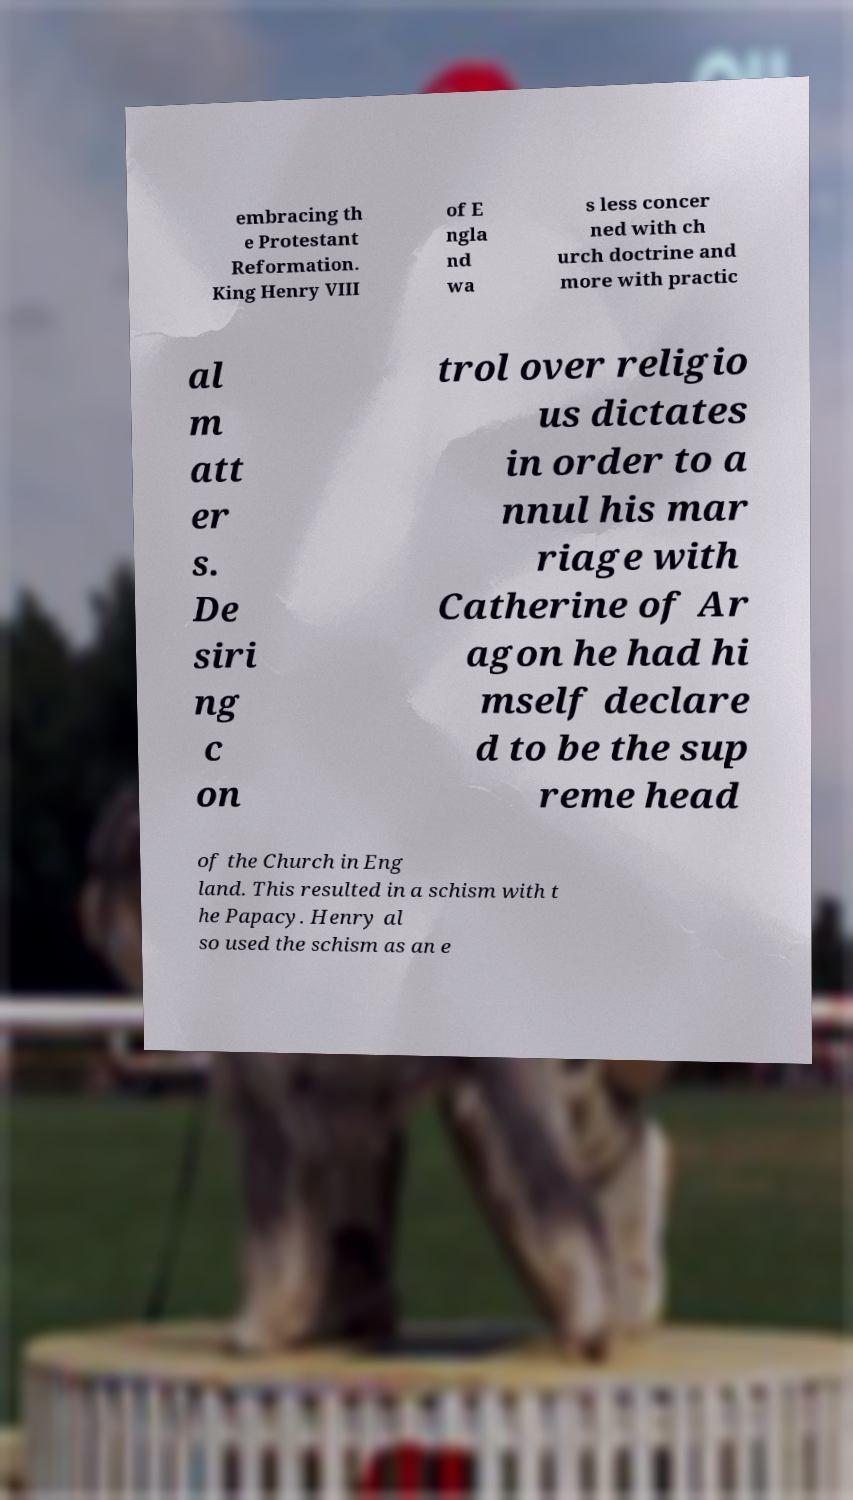Please identify and transcribe the text found in this image. embracing th e Protestant Reformation. King Henry VIII of E ngla nd wa s less concer ned with ch urch doctrine and more with practic al m att er s. De siri ng c on trol over religio us dictates in order to a nnul his mar riage with Catherine of Ar agon he had hi mself declare d to be the sup reme head of the Church in Eng land. This resulted in a schism with t he Papacy. Henry al so used the schism as an e 